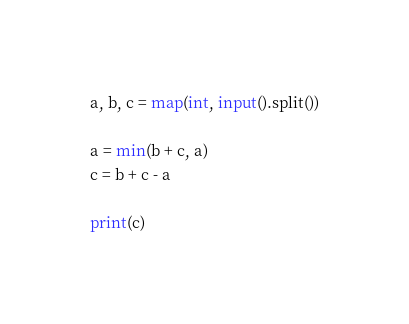Convert code to text. <code><loc_0><loc_0><loc_500><loc_500><_Python_>a, b, c = map(int, input().split())

a = min(b + c, a)
c = b + c - a

print(c)</code> 